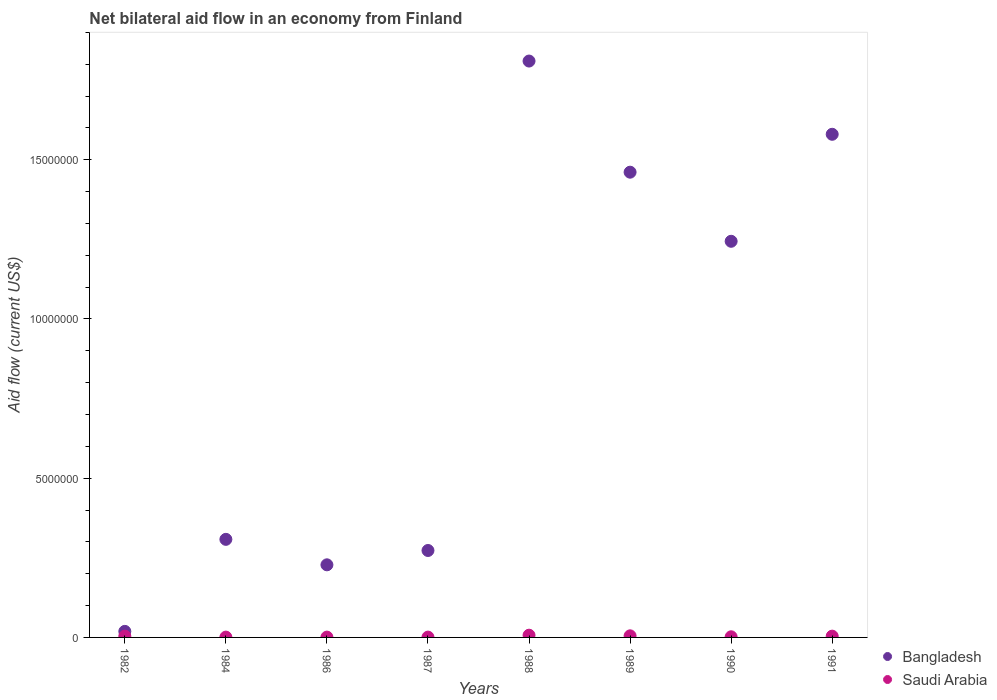What is the net bilateral aid flow in Bangladesh in 1982?
Offer a very short reply. 1.90e+05. Across all years, what is the maximum net bilateral aid flow in Bangladesh?
Give a very brief answer. 1.81e+07. What is the difference between the net bilateral aid flow in Bangladesh in 1989 and that in 1991?
Your response must be concise. -1.19e+06. What is the difference between the net bilateral aid flow in Bangladesh in 1990 and the net bilateral aid flow in Saudi Arabia in 1982?
Provide a short and direct response. 1.24e+07. What is the average net bilateral aid flow in Saudi Arabia per year?
Ensure brevity in your answer.  3.12e+04. In the year 1987, what is the difference between the net bilateral aid flow in Saudi Arabia and net bilateral aid flow in Bangladesh?
Your response must be concise. -2.72e+06. Is the net bilateral aid flow in Bangladesh in 1988 less than that in 1989?
Make the answer very short. No. Is the difference between the net bilateral aid flow in Saudi Arabia in 1984 and 1991 greater than the difference between the net bilateral aid flow in Bangladesh in 1984 and 1991?
Offer a terse response. Yes. What is the difference between the highest and the second highest net bilateral aid flow in Saudi Arabia?
Ensure brevity in your answer.  2.00e+04. What is the difference between the highest and the lowest net bilateral aid flow in Bangladesh?
Your answer should be very brief. 1.79e+07. Does the net bilateral aid flow in Bangladesh monotonically increase over the years?
Offer a very short reply. No. What is the difference between two consecutive major ticks on the Y-axis?
Your response must be concise. 5.00e+06. Does the graph contain grids?
Your answer should be compact. No. How many legend labels are there?
Your answer should be compact. 2. How are the legend labels stacked?
Make the answer very short. Vertical. What is the title of the graph?
Keep it short and to the point. Net bilateral aid flow in an economy from Finland. Does "Arab World" appear as one of the legend labels in the graph?
Your answer should be very brief. No. What is the label or title of the X-axis?
Make the answer very short. Years. What is the label or title of the Y-axis?
Provide a short and direct response. Aid flow (current US$). What is the Aid flow (current US$) of Bangladesh in 1982?
Ensure brevity in your answer.  1.90e+05. What is the Aid flow (current US$) of Saudi Arabia in 1982?
Offer a terse response. 4.00e+04. What is the Aid flow (current US$) of Bangladesh in 1984?
Your response must be concise. 3.08e+06. What is the Aid flow (current US$) in Bangladesh in 1986?
Make the answer very short. 2.28e+06. What is the Aid flow (current US$) in Bangladesh in 1987?
Provide a short and direct response. 2.73e+06. What is the Aid flow (current US$) of Saudi Arabia in 1987?
Offer a terse response. 10000. What is the Aid flow (current US$) in Bangladesh in 1988?
Your answer should be compact. 1.81e+07. What is the Aid flow (current US$) in Bangladesh in 1989?
Provide a short and direct response. 1.46e+07. What is the Aid flow (current US$) in Saudi Arabia in 1989?
Give a very brief answer. 5.00e+04. What is the Aid flow (current US$) of Bangladesh in 1990?
Ensure brevity in your answer.  1.24e+07. What is the Aid flow (current US$) in Saudi Arabia in 1990?
Provide a succinct answer. 2.00e+04. What is the Aid flow (current US$) in Bangladesh in 1991?
Keep it short and to the point. 1.58e+07. Across all years, what is the maximum Aid flow (current US$) of Bangladesh?
Make the answer very short. 1.81e+07. Across all years, what is the maximum Aid flow (current US$) of Saudi Arabia?
Offer a very short reply. 7.00e+04. Across all years, what is the minimum Aid flow (current US$) of Saudi Arabia?
Your answer should be very brief. 10000. What is the total Aid flow (current US$) in Bangladesh in the graph?
Make the answer very short. 6.92e+07. What is the total Aid flow (current US$) in Saudi Arabia in the graph?
Keep it short and to the point. 2.50e+05. What is the difference between the Aid flow (current US$) of Bangladesh in 1982 and that in 1984?
Make the answer very short. -2.89e+06. What is the difference between the Aid flow (current US$) in Saudi Arabia in 1982 and that in 1984?
Your answer should be very brief. 3.00e+04. What is the difference between the Aid flow (current US$) in Bangladesh in 1982 and that in 1986?
Give a very brief answer. -2.09e+06. What is the difference between the Aid flow (current US$) of Bangladesh in 1982 and that in 1987?
Offer a very short reply. -2.54e+06. What is the difference between the Aid flow (current US$) in Saudi Arabia in 1982 and that in 1987?
Provide a succinct answer. 3.00e+04. What is the difference between the Aid flow (current US$) of Bangladesh in 1982 and that in 1988?
Your answer should be compact. -1.79e+07. What is the difference between the Aid flow (current US$) of Bangladesh in 1982 and that in 1989?
Offer a very short reply. -1.44e+07. What is the difference between the Aid flow (current US$) in Saudi Arabia in 1982 and that in 1989?
Make the answer very short. -10000. What is the difference between the Aid flow (current US$) of Bangladesh in 1982 and that in 1990?
Offer a very short reply. -1.22e+07. What is the difference between the Aid flow (current US$) in Bangladesh in 1982 and that in 1991?
Make the answer very short. -1.56e+07. What is the difference between the Aid flow (current US$) in Saudi Arabia in 1984 and that in 1986?
Offer a very short reply. 0. What is the difference between the Aid flow (current US$) in Bangladesh in 1984 and that in 1988?
Offer a very short reply. -1.50e+07. What is the difference between the Aid flow (current US$) in Saudi Arabia in 1984 and that in 1988?
Your answer should be compact. -6.00e+04. What is the difference between the Aid flow (current US$) in Bangladesh in 1984 and that in 1989?
Offer a terse response. -1.15e+07. What is the difference between the Aid flow (current US$) in Saudi Arabia in 1984 and that in 1989?
Offer a very short reply. -4.00e+04. What is the difference between the Aid flow (current US$) in Bangladesh in 1984 and that in 1990?
Offer a terse response. -9.36e+06. What is the difference between the Aid flow (current US$) in Bangladesh in 1984 and that in 1991?
Offer a terse response. -1.27e+07. What is the difference between the Aid flow (current US$) of Saudi Arabia in 1984 and that in 1991?
Your answer should be very brief. -3.00e+04. What is the difference between the Aid flow (current US$) in Bangladesh in 1986 and that in 1987?
Provide a succinct answer. -4.50e+05. What is the difference between the Aid flow (current US$) of Bangladesh in 1986 and that in 1988?
Provide a succinct answer. -1.58e+07. What is the difference between the Aid flow (current US$) of Bangladesh in 1986 and that in 1989?
Your answer should be compact. -1.23e+07. What is the difference between the Aid flow (current US$) of Bangladesh in 1986 and that in 1990?
Offer a very short reply. -1.02e+07. What is the difference between the Aid flow (current US$) in Saudi Arabia in 1986 and that in 1990?
Offer a very short reply. -10000. What is the difference between the Aid flow (current US$) in Bangladesh in 1986 and that in 1991?
Ensure brevity in your answer.  -1.35e+07. What is the difference between the Aid flow (current US$) in Saudi Arabia in 1986 and that in 1991?
Provide a succinct answer. -3.00e+04. What is the difference between the Aid flow (current US$) in Bangladesh in 1987 and that in 1988?
Give a very brief answer. -1.54e+07. What is the difference between the Aid flow (current US$) in Bangladesh in 1987 and that in 1989?
Offer a terse response. -1.19e+07. What is the difference between the Aid flow (current US$) of Saudi Arabia in 1987 and that in 1989?
Provide a short and direct response. -4.00e+04. What is the difference between the Aid flow (current US$) of Bangladesh in 1987 and that in 1990?
Make the answer very short. -9.71e+06. What is the difference between the Aid flow (current US$) in Saudi Arabia in 1987 and that in 1990?
Ensure brevity in your answer.  -10000. What is the difference between the Aid flow (current US$) of Bangladesh in 1987 and that in 1991?
Ensure brevity in your answer.  -1.31e+07. What is the difference between the Aid flow (current US$) in Saudi Arabia in 1987 and that in 1991?
Keep it short and to the point. -3.00e+04. What is the difference between the Aid flow (current US$) of Bangladesh in 1988 and that in 1989?
Keep it short and to the point. 3.49e+06. What is the difference between the Aid flow (current US$) in Saudi Arabia in 1988 and that in 1989?
Make the answer very short. 2.00e+04. What is the difference between the Aid flow (current US$) of Bangladesh in 1988 and that in 1990?
Ensure brevity in your answer.  5.66e+06. What is the difference between the Aid flow (current US$) in Saudi Arabia in 1988 and that in 1990?
Provide a succinct answer. 5.00e+04. What is the difference between the Aid flow (current US$) in Bangladesh in 1988 and that in 1991?
Provide a succinct answer. 2.30e+06. What is the difference between the Aid flow (current US$) in Bangladesh in 1989 and that in 1990?
Your response must be concise. 2.17e+06. What is the difference between the Aid flow (current US$) in Saudi Arabia in 1989 and that in 1990?
Offer a very short reply. 3.00e+04. What is the difference between the Aid flow (current US$) of Bangladesh in 1989 and that in 1991?
Ensure brevity in your answer.  -1.19e+06. What is the difference between the Aid flow (current US$) of Saudi Arabia in 1989 and that in 1991?
Keep it short and to the point. 10000. What is the difference between the Aid flow (current US$) of Bangladesh in 1990 and that in 1991?
Keep it short and to the point. -3.36e+06. What is the difference between the Aid flow (current US$) in Saudi Arabia in 1990 and that in 1991?
Provide a short and direct response. -2.00e+04. What is the difference between the Aid flow (current US$) in Bangladesh in 1982 and the Aid flow (current US$) in Saudi Arabia in 1986?
Your answer should be compact. 1.80e+05. What is the difference between the Aid flow (current US$) in Bangladesh in 1982 and the Aid flow (current US$) in Saudi Arabia in 1988?
Your answer should be very brief. 1.20e+05. What is the difference between the Aid flow (current US$) in Bangladesh in 1982 and the Aid flow (current US$) in Saudi Arabia in 1991?
Provide a succinct answer. 1.50e+05. What is the difference between the Aid flow (current US$) of Bangladesh in 1984 and the Aid flow (current US$) of Saudi Arabia in 1986?
Ensure brevity in your answer.  3.07e+06. What is the difference between the Aid flow (current US$) in Bangladesh in 1984 and the Aid flow (current US$) in Saudi Arabia in 1987?
Your response must be concise. 3.07e+06. What is the difference between the Aid flow (current US$) of Bangladesh in 1984 and the Aid flow (current US$) of Saudi Arabia in 1988?
Your answer should be very brief. 3.01e+06. What is the difference between the Aid flow (current US$) of Bangladesh in 1984 and the Aid flow (current US$) of Saudi Arabia in 1989?
Provide a short and direct response. 3.03e+06. What is the difference between the Aid flow (current US$) in Bangladesh in 1984 and the Aid flow (current US$) in Saudi Arabia in 1990?
Make the answer very short. 3.06e+06. What is the difference between the Aid flow (current US$) of Bangladesh in 1984 and the Aid flow (current US$) of Saudi Arabia in 1991?
Keep it short and to the point. 3.04e+06. What is the difference between the Aid flow (current US$) of Bangladesh in 1986 and the Aid flow (current US$) of Saudi Arabia in 1987?
Ensure brevity in your answer.  2.27e+06. What is the difference between the Aid flow (current US$) of Bangladesh in 1986 and the Aid flow (current US$) of Saudi Arabia in 1988?
Ensure brevity in your answer.  2.21e+06. What is the difference between the Aid flow (current US$) in Bangladesh in 1986 and the Aid flow (current US$) in Saudi Arabia in 1989?
Your answer should be very brief. 2.23e+06. What is the difference between the Aid flow (current US$) of Bangladesh in 1986 and the Aid flow (current US$) of Saudi Arabia in 1990?
Ensure brevity in your answer.  2.26e+06. What is the difference between the Aid flow (current US$) in Bangladesh in 1986 and the Aid flow (current US$) in Saudi Arabia in 1991?
Your answer should be compact. 2.24e+06. What is the difference between the Aid flow (current US$) of Bangladesh in 1987 and the Aid flow (current US$) of Saudi Arabia in 1988?
Offer a very short reply. 2.66e+06. What is the difference between the Aid flow (current US$) in Bangladesh in 1987 and the Aid flow (current US$) in Saudi Arabia in 1989?
Keep it short and to the point. 2.68e+06. What is the difference between the Aid flow (current US$) of Bangladesh in 1987 and the Aid flow (current US$) of Saudi Arabia in 1990?
Offer a very short reply. 2.71e+06. What is the difference between the Aid flow (current US$) in Bangladesh in 1987 and the Aid flow (current US$) in Saudi Arabia in 1991?
Your answer should be compact. 2.69e+06. What is the difference between the Aid flow (current US$) of Bangladesh in 1988 and the Aid flow (current US$) of Saudi Arabia in 1989?
Offer a terse response. 1.80e+07. What is the difference between the Aid flow (current US$) in Bangladesh in 1988 and the Aid flow (current US$) in Saudi Arabia in 1990?
Make the answer very short. 1.81e+07. What is the difference between the Aid flow (current US$) of Bangladesh in 1988 and the Aid flow (current US$) of Saudi Arabia in 1991?
Your answer should be very brief. 1.81e+07. What is the difference between the Aid flow (current US$) in Bangladesh in 1989 and the Aid flow (current US$) in Saudi Arabia in 1990?
Make the answer very short. 1.46e+07. What is the difference between the Aid flow (current US$) of Bangladesh in 1989 and the Aid flow (current US$) of Saudi Arabia in 1991?
Your answer should be compact. 1.46e+07. What is the difference between the Aid flow (current US$) of Bangladesh in 1990 and the Aid flow (current US$) of Saudi Arabia in 1991?
Your response must be concise. 1.24e+07. What is the average Aid flow (current US$) in Bangladesh per year?
Provide a short and direct response. 8.65e+06. What is the average Aid flow (current US$) of Saudi Arabia per year?
Give a very brief answer. 3.12e+04. In the year 1982, what is the difference between the Aid flow (current US$) in Bangladesh and Aid flow (current US$) in Saudi Arabia?
Give a very brief answer. 1.50e+05. In the year 1984, what is the difference between the Aid flow (current US$) of Bangladesh and Aid flow (current US$) of Saudi Arabia?
Give a very brief answer. 3.07e+06. In the year 1986, what is the difference between the Aid flow (current US$) in Bangladesh and Aid flow (current US$) in Saudi Arabia?
Offer a terse response. 2.27e+06. In the year 1987, what is the difference between the Aid flow (current US$) in Bangladesh and Aid flow (current US$) in Saudi Arabia?
Provide a short and direct response. 2.72e+06. In the year 1988, what is the difference between the Aid flow (current US$) of Bangladesh and Aid flow (current US$) of Saudi Arabia?
Keep it short and to the point. 1.80e+07. In the year 1989, what is the difference between the Aid flow (current US$) of Bangladesh and Aid flow (current US$) of Saudi Arabia?
Give a very brief answer. 1.46e+07. In the year 1990, what is the difference between the Aid flow (current US$) in Bangladesh and Aid flow (current US$) in Saudi Arabia?
Offer a terse response. 1.24e+07. In the year 1991, what is the difference between the Aid flow (current US$) in Bangladesh and Aid flow (current US$) in Saudi Arabia?
Keep it short and to the point. 1.58e+07. What is the ratio of the Aid flow (current US$) of Bangladesh in 1982 to that in 1984?
Your response must be concise. 0.06. What is the ratio of the Aid flow (current US$) of Bangladesh in 1982 to that in 1986?
Offer a very short reply. 0.08. What is the ratio of the Aid flow (current US$) in Saudi Arabia in 1982 to that in 1986?
Your answer should be very brief. 4. What is the ratio of the Aid flow (current US$) of Bangladesh in 1982 to that in 1987?
Make the answer very short. 0.07. What is the ratio of the Aid flow (current US$) in Saudi Arabia in 1982 to that in 1987?
Your answer should be compact. 4. What is the ratio of the Aid flow (current US$) of Bangladesh in 1982 to that in 1988?
Your response must be concise. 0.01. What is the ratio of the Aid flow (current US$) in Bangladesh in 1982 to that in 1989?
Keep it short and to the point. 0.01. What is the ratio of the Aid flow (current US$) of Saudi Arabia in 1982 to that in 1989?
Offer a terse response. 0.8. What is the ratio of the Aid flow (current US$) in Bangladesh in 1982 to that in 1990?
Offer a very short reply. 0.02. What is the ratio of the Aid flow (current US$) in Bangladesh in 1982 to that in 1991?
Provide a short and direct response. 0.01. What is the ratio of the Aid flow (current US$) of Bangladesh in 1984 to that in 1986?
Offer a very short reply. 1.35. What is the ratio of the Aid flow (current US$) in Saudi Arabia in 1984 to that in 1986?
Give a very brief answer. 1. What is the ratio of the Aid flow (current US$) of Bangladesh in 1984 to that in 1987?
Offer a terse response. 1.13. What is the ratio of the Aid flow (current US$) in Saudi Arabia in 1984 to that in 1987?
Provide a succinct answer. 1. What is the ratio of the Aid flow (current US$) of Bangladesh in 1984 to that in 1988?
Your answer should be compact. 0.17. What is the ratio of the Aid flow (current US$) in Saudi Arabia in 1984 to that in 1988?
Provide a short and direct response. 0.14. What is the ratio of the Aid flow (current US$) of Bangladesh in 1984 to that in 1989?
Provide a succinct answer. 0.21. What is the ratio of the Aid flow (current US$) of Saudi Arabia in 1984 to that in 1989?
Your response must be concise. 0.2. What is the ratio of the Aid flow (current US$) in Bangladesh in 1984 to that in 1990?
Give a very brief answer. 0.25. What is the ratio of the Aid flow (current US$) of Bangladesh in 1984 to that in 1991?
Your response must be concise. 0.19. What is the ratio of the Aid flow (current US$) in Bangladesh in 1986 to that in 1987?
Make the answer very short. 0.84. What is the ratio of the Aid flow (current US$) of Bangladesh in 1986 to that in 1988?
Offer a terse response. 0.13. What is the ratio of the Aid flow (current US$) of Saudi Arabia in 1986 to that in 1988?
Keep it short and to the point. 0.14. What is the ratio of the Aid flow (current US$) of Bangladesh in 1986 to that in 1989?
Offer a very short reply. 0.16. What is the ratio of the Aid flow (current US$) in Bangladesh in 1986 to that in 1990?
Offer a very short reply. 0.18. What is the ratio of the Aid flow (current US$) in Saudi Arabia in 1986 to that in 1990?
Keep it short and to the point. 0.5. What is the ratio of the Aid flow (current US$) in Bangladesh in 1986 to that in 1991?
Your answer should be compact. 0.14. What is the ratio of the Aid flow (current US$) of Saudi Arabia in 1986 to that in 1991?
Make the answer very short. 0.25. What is the ratio of the Aid flow (current US$) in Bangladesh in 1987 to that in 1988?
Your response must be concise. 0.15. What is the ratio of the Aid flow (current US$) of Saudi Arabia in 1987 to that in 1988?
Ensure brevity in your answer.  0.14. What is the ratio of the Aid flow (current US$) in Bangladesh in 1987 to that in 1989?
Give a very brief answer. 0.19. What is the ratio of the Aid flow (current US$) in Saudi Arabia in 1987 to that in 1989?
Your answer should be very brief. 0.2. What is the ratio of the Aid flow (current US$) of Bangladesh in 1987 to that in 1990?
Provide a short and direct response. 0.22. What is the ratio of the Aid flow (current US$) of Saudi Arabia in 1987 to that in 1990?
Your response must be concise. 0.5. What is the ratio of the Aid flow (current US$) of Bangladesh in 1987 to that in 1991?
Give a very brief answer. 0.17. What is the ratio of the Aid flow (current US$) in Bangladesh in 1988 to that in 1989?
Provide a succinct answer. 1.24. What is the ratio of the Aid flow (current US$) in Saudi Arabia in 1988 to that in 1989?
Your response must be concise. 1.4. What is the ratio of the Aid flow (current US$) in Bangladesh in 1988 to that in 1990?
Make the answer very short. 1.46. What is the ratio of the Aid flow (current US$) of Saudi Arabia in 1988 to that in 1990?
Offer a very short reply. 3.5. What is the ratio of the Aid flow (current US$) in Bangladesh in 1988 to that in 1991?
Ensure brevity in your answer.  1.15. What is the ratio of the Aid flow (current US$) of Saudi Arabia in 1988 to that in 1991?
Give a very brief answer. 1.75. What is the ratio of the Aid flow (current US$) of Bangladesh in 1989 to that in 1990?
Your response must be concise. 1.17. What is the ratio of the Aid flow (current US$) of Saudi Arabia in 1989 to that in 1990?
Offer a terse response. 2.5. What is the ratio of the Aid flow (current US$) in Bangladesh in 1989 to that in 1991?
Provide a short and direct response. 0.92. What is the ratio of the Aid flow (current US$) of Bangladesh in 1990 to that in 1991?
Your answer should be compact. 0.79. What is the difference between the highest and the second highest Aid flow (current US$) in Bangladesh?
Give a very brief answer. 2.30e+06. What is the difference between the highest and the lowest Aid flow (current US$) of Bangladesh?
Your answer should be compact. 1.79e+07. What is the difference between the highest and the lowest Aid flow (current US$) in Saudi Arabia?
Ensure brevity in your answer.  6.00e+04. 